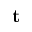Convert formula to latex. <formula><loc_0><loc_0><loc_500><loc_500>t</formula> 